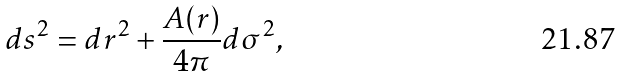<formula> <loc_0><loc_0><loc_500><loc_500>d s ^ { 2 } = d r ^ { 2 } + \frac { A ( r ) } { 4 \pi } d \sigma ^ { 2 } ,</formula> 